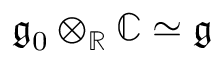<formula> <loc_0><loc_0><loc_500><loc_500>{ \mathfrak { g } } _ { 0 } \otimes _ { \mathbb { R } } \mathbb { C } \simeq { \mathfrak { g } }</formula> 